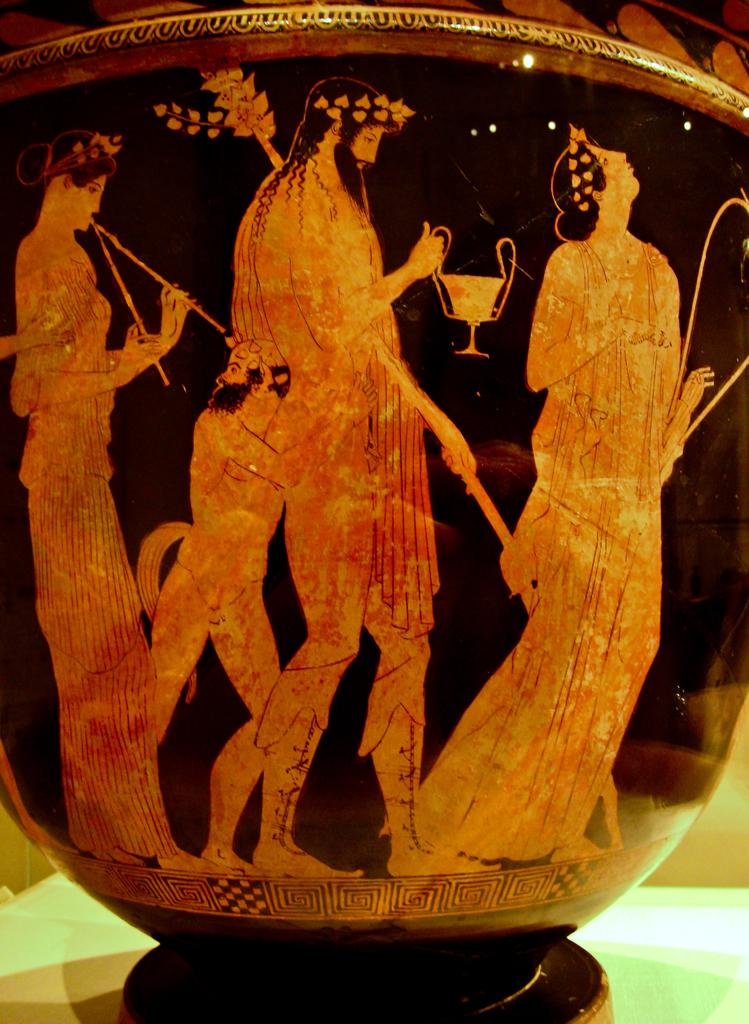What is the main subject of the picture? There is an object in the picture. What can be seen on the object? The object has art designs of people. Where is the rabbit hiding in the picture? There is no rabbit present in the picture; it only features an object with art designs of people. 